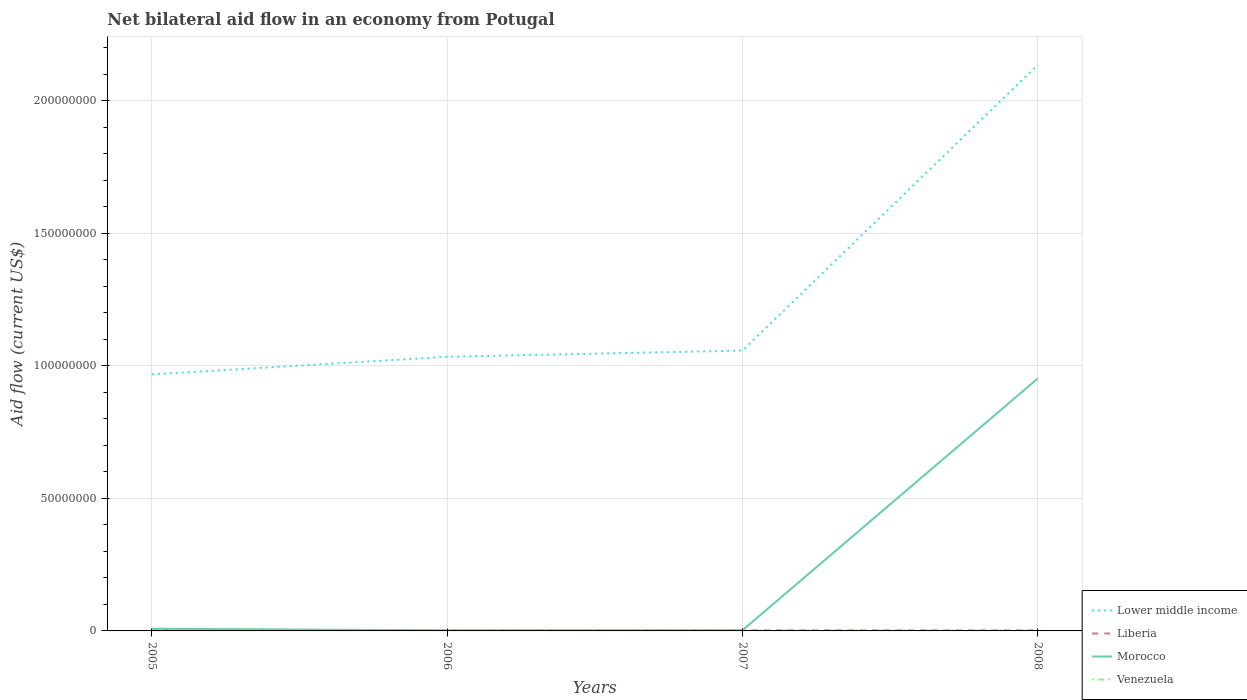How many different coloured lines are there?
Your answer should be very brief. 4. Does the line corresponding to Morocco intersect with the line corresponding to Liberia?
Your response must be concise. No. Across all years, what is the maximum net bilateral aid flow in Lower middle income?
Your answer should be very brief. 9.68e+07. In which year was the net bilateral aid flow in Morocco maximum?
Your answer should be very brief. 2006. What is the total net bilateral aid flow in Morocco in the graph?
Your answer should be compact. -9.50e+07. Is the net bilateral aid flow in Lower middle income strictly greater than the net bilateral aid flow in Morocco over the years?
Provide a succinct answer. No. How many lines are there?
Your answer should be very brief. 4. How many years are there in the graph?
Provide a short and direct response. 4. What is the difference between two consecutive major ticks on the Y-axis?
Make the answer very short. 5.00e+07. Does the graph contain any zero values?
Offer a terse response. No. Does the graph contain grids?
Offer a terse response. Yes. Where does the legend appear in the graph?
Ensure brevity in your answer.  Bottom right. How many legend labels are there?
Offer a terse response. 4. How are the legend labels stacked?
Your answer should be very brief. Vertical. What is the title of the graph?
Give a very brief answer. Net bilateral aid flow in an economy from Potugal. What is the Aid flow (current US$) of Lower middle income in 2005?
Your answer should be very brief. 9.68e+07. What is the Aid flow (current US$) in Liberia in 2005?
Make the answer very short. 5.80e+05. What is the Aid flow (current US$) in Morocco in 2005?
Offer a terse response. 8.30e+05. What is the Aid flow (current US$) of Venezuela in 2005?
Keep it short and to the point. 1.00e+05. What is the Aid flow (current US$) of Lower middle income in 2006?
Ensure brevity in your answer.  1.03e+08. What is the Aid flow (current US$) of Morocco in 2006?
Your response must be concise. 2.30e+05. What is the Aid flow (current US$) in Venezuela in 2006?
Your answer should be compact. 1.10e+05. What is the Aid flow (current US$) of Lower middle income in 2007?
Keep it short and to the point. 1.06e+08. What is the Aid flow (current US$) in Morocco in 2007?
Your answer should be very brief. 2.60e+05. What is the Aid flow (current US$) of Lower middle income in 2008?
Make the answer very short. 2.14e+08. What is the Aid flow (current US$) in Morocco in 2008?
Make the answer very short. 9.53e+07. Across all years, what is the maximum Aid flow (current US$) in Lower middle income?
Offer a terse response. 2.14e+08. Across all years, what is the maximum Aid flow (current US$) of Liberia?
Your answer should be very brief. 5.80e+05. Across all years, what is the maximum Aid flow (current US$) of Morocco?
Keep it short and to the point. 9.53e+07. Across all years, what is the maximum Aid flow (current US$) in Venezuela?
Offer a terse response. 1.50e+05. Across all years, what is the minimum Aid flow (current US$) of Lower middle income?
Provide a succinct answer. 9.68e+07. Across all years, what is the minimum Aid flow (current US$) in Liberia?
Keep it short and to the point. 1.80e+05. Across all years, what is the minimum Aid flow (current US$) of Morocco?
Your answer should be compact. 2.30e+05. What is the total Aid flow (current US$) in Lower middle income in the graph?
Your answer should be very brief. 5.20e+08. What is the total Aid flow (current US$) of Liberia in the graph?
Provide a short and direct response. 1.21e+06. What is the total Aid flow (current US$) in Morocco in the graph?
Ensure brevity in your answer.  9.66e+07. What is the difference between the Aid flow (current US$) of Lower middle income in 2005 and that in 2006?
Give a very brief answer. -6.64e+06. What is the difference between the Aid flow (current US$) of Liberia in 2005 and that in 2006?
Make the answer very short. 4.00e+05. What is the difference between the Aid flow (current US$) in Venezuela in 2005 and that in 2006?
Provide a short and direct response. -10000. What is the difference between the Aid flow (current US$) in Lower middle income in 2005 and that in 2007?
Your response must be concise. -8.99e+06. What is the difference between the Aid flow (current US$) of Morocco in 2005 and that in 2007?
Your answer should be compact. 5.70e+05. What is the difference between the Aid flow (current US$) of Lower middle income in 2005 and that in 2008?
Make the answer very short. -1.17e+08. What is the difference between the Aid flow (current US$) of Liberia in 2005 and that in 2008?
Provide a short and direct response. 3.70e+05. What is the difference between the Aid flow (current US$) of Morocco in 2005 and that in 2008?
Provide a succinct answer. -9.45e+07. What is the difference between the Aid flow (current US$) in Lower middle income in 2006 and that in 2007?
Offer a terse response. -2.35e+06. What is the difference between the Aid flow (current US$) in Liberia in 2006 and that in 2007?
Your response must be concise. -6.00e+04. What is the difference between the Aid flow (current US$) in Morocco in 2006 and that in 2007?
Offer a very short reply. -3.00e+04. What is the difference between the Aid flow (current US$) in Lower middle income in 2006 and that in 2008?
Make the answer very short. -1.10e+08. What is the difference between the Aid flow (current US$) of Liberia in 2006 and that in 2008?
Keep it short and to the point. -3.00e+04. What is the difference between the Aid flow (current US$) of Morocco in 2006 and that in 2008?
Your response must be concise. -9.51e+07. What is the difference between the Aid flow (current US$) of Venezuela in 2006 and that in 2008?
Your response must be concise. -10000. What is the difference between the Aid flow (current US$) of Lower middle income in 2007 and that in 2008?
Your answer should be compact. -1.08e+08. What is the difference between the Aid flow (current US$) in Morocco in 2007 and that in 2008?
Offer a terse response. -9.50e+07. What is the difference between the Aid flow (current US$) of Lower middle income in 2005 and the Aid flow (current US$) of Liberia in 2006?
Your response must be concise. 9.66e+07. What is the difference between the Aid flow (current US$) of Lower middle income in 2005 and the Aid flow (current US$) of Morocco in 2006?
Offer a terse response. 9.66e+07. What is the difference between the Aid flow (current US$) of Lower middle income in 2005 and the Aid flow (current US$) of Venezuela in 2006?
Provide a succinct answer. 9.67e+07. What is the difference between the Aid flow (current US$) in Liberia in 2005 and the Aid flow (current US$) in Venezuela in 2006?
Your answer should be compact. 4.70e+05. What is the difference between the Aid flow (current US$) of Morocco in 2005 and the Aid flow (current US$) of Venezuela in 2006?
Offer a very short reply. 7.20e+05. What is the difference between the Aid flow (current US$) of Lower middle income in 2005 and the Aid flow (current US$) of Liberia in 2007?
Offer a very short reply. 9.66e+07. What is the difference between the Aid flow (current US$) in Lower middle income in 2005 and the Aid flow (current US$) in Morocco in 2007?
Provide a short and direct response. 9.66e+07. What is the difference between the Aid flow (current US$) in Lower middle income in 2005 and the Aid flow (current US$) in Venezuela in 2007?
Offer a very short reply. 9.67e+07. What is the difference between the Aid flow (current US$) in Liberia in 2005 and the Aid flow (current US$) in Morocco in 2007?
Offer a terse response. 3.20e+05. What is the difference between the Aid flow (current US$) in Morocco in 2005 and the Aid flow (current US$) in Venezuela in 2007?
Provide a succinct answer. 6.80e+05. What is the difference between the Aid flow (current US$) in Lower middle income in 2005 and the Aid flow (current US$) in Liberia in 2008?
Offer a terse response. 9.66e+07. What is the difference between the Aid flow (current US$) in Lower middle income in 2005 and the Aid flow (current US$) in Morocco in 2008?
Provide a succinct answer. 1.51e+06. What is the difference between the Aid flow (current US$) of Lower middle income in 2005 and the Aid flow (current US$) of Venezuela in 2008?
Give a very brief answer. 9.67e+07. What is the difference between the Aid flow (current US$) in Liberia in 2005 and the Aid flow (current US$) in Morocco in 2008?
Give a very brief answer. -9.47e+07. What is the difference between the Aid flow (current US$) in Liberia in 2005 and the Aid flow (current US$) in Venezuela in 2008?
Keep it short and to the point. 4.60e+05. What is the difference between the Aid flow (current US$) of Morocco in 2005 and the Aid flow (current US$) of Venezuela in 2008?
Provide a short and direct response. 7.10e+05. What is the difference between the Aid flow (current US$) in Lower middle income in 2006 and the Aid flow (current US$) in Liberia in 2007?
Provide a short and direct response. 1.03e+08. What is the difference between the Aid flow (current US$) in Lower middle income in 2006 and the Aid flow (current US$) in Morocco in 2007?
Your answer should be very brief. 1.03e+08. What is the difference between the Aid flow (current US$) in Lower middle income in 2006 and the Aid flow (current US$) in Venezuela in 2007?
Give a very brief answer. 1.03e+08. What is the difference between the Aid flow (current US$) of Liberia in 2006 and the Aid flow (current US$) of Morocco in 2007?
Provide a short and direct response. -8.00e+04. What is the difference between the Aid flow (current US$) in Lower middle income in 2006 and the Aid flow (current US$) in Liberia in 2008?
Your answer should be very brief. 1.03e+08. What is the difference between the Aid flow (current US$) of Lower middle income in 2006 and the Aid flow (current US$) of Morocco in 2008?
Ensure brevity in your answer.  8.15e+06. What is the difference between the Aid flow (current US$) in Lower middle income in 2006 and the Aid flow (current US$) in Venezuela in 2008?
Offer a very short reply. 1.03e+08. What is the difference between the Aid flow (current US$) in Liberia in 2006 and the Aid flow (current US$) in Morocco in 2008?
Ensure brevity in your answer.  -9.51e+07. What is the difference between the Aid flow (current US$) of Liberia in 2006 and the Aid flow (current US$) of Venezuela in 2008?
Keep it short and to the point. 6.00e+04. What is the difference between the Aid flow (current US$) in Morocco in 2006 and the Aid flow (current US$) in Venezuela in 2008?
Ensure brevity in your answer.  1.10e+05. What is the difference between the Aid flow (current US$) of Lower middle income in 2007 and the Aid flow (current US$) of Liberia in 2008?
Your answer should be compact. 1.06e+08. What is the difference between the Aid flow (current US$) in Lower middle income in 2007 and the Aid flow (current US$) in Morocco in 2008?
Keep it short and to the point. 1.05e+07. What is the difference between the Aid flow (current US$) of Lower middle income in 2007 and the Aid flow (current US$) of Venezuela in 2008?
Keep it short and to the point. 1.06e+08. What is the difference between the Aid flow (current US$) of Liberia in 2007 and the Aid flow (current US$) of Morocco in 2008?
Give a very brief answer. -9.51e+07. What is the difference between the Aid flow (current US$) of Liberia in 2007 and the Aid flow (current US$) of Venezuela in 2008?
Your answer should be compact. 1.20e+05. What is the difference between the Aid flow (current US$) in Morocco in 2007 and the Aid flow (current US$) in Venezuela in 2008?
Your response must be concise. 1.40e+05. What is the average Aid flow (current US$) in Lower middle income per year?
Offer a terse response. 1.30e+08. What is the average Aid flow (current US$) in Liberia per year?
Give a very brief answer. 3.02e+05. What is the average Aid flow (current US$) of Morocco per year?
Provide a succinct answer. 2.42e+07. What is the average Aid flow (current US$) in Venezuela per year?
Offer a very short reply. 1.20e+05. In the year 2005, what is the difference between the Aid flow (current US$) in Lower middle income and Aid flow (current US$) in Liberia?
Offer a terse response. 9.62e+07. In the year 2005, what is the difference between the Aid flow (current US$) of Lower middle income and Aid flow (current US$) of Morocco?
Your answer should be very brief. 9.60e+07. In the year 2005, what is the difference between the Aid flow (current US$) in Lower middle income and Aid flow (current US$) in Venezuela?
Offer a very short reply. 9.67e+07. In the year 2005, what is the difference between the Aid flow (current US$) of Liberia and Aid flow (current US$) of Venezuela?
Your answer should be compact. 4.80e+05. In the year 2005, what is the difference between the Aid flow (current US$) of Morocco and Aid flow (current US$) of Venezuela?
Keep it short and to the point. 7.30e+05. In the year 2006, what is the difference between the Aid flow (current US$) in Lower middle income and Aid flow (current US$) in Liberia?
Keep it short and to the point. 1.03e+08. In the year 2006, what is the difference between the Aid flow (current US$) in Lower middle income and Aid flow (current US$) in Morocco?
Provide a short and direct response. 1.03e+08. In the year 2006, what is the difference between the Aid flow (current US$) in Lower middle income and Aid flow (current US$) in Venezuela?
Offer a very short reply. 1.03e+08. In the year 2007, what is the difference between the Aid flow (current US$) of Lower middle income and Aid flow (current US$) of Liberia?
Provide a short and direct response. 1.06e+08. In the year 2007, what is the difference between the Aid flow (current US$) of Lower middle income and Aid flow (current US$) of Morocco?
Your response must be concise. 1.06e+08. In the year 2007, what is the difference between the Aid flow (current US$) in Lower middle income and Aid flow (current US$) in Venezuela?
Provide a short and direct response. 1.06e+08. In the year 2007, what is the difference between the Aid flow (current US$) of Liberia and Aid flow (current US$) of Venezuela?
Ensure brevity in your answer.  9.00e+04. In the year 2007, what is the difference between the Aid flow (current US$) of Morocco and Aid flow (current US$) of Venezuela?
Make the answer very short. 1.10e+05. In the year 2008, what is the difference between the Aid flow (current US$) of Lower middle income and Aid flow (current US$) of Liberia?
Provide a short and direct response. 2.13e+08. In the year 2008, what is the difference between the Aid flow (current US$) in Lower middle income and Aid flow (current US$) in Morocco?
Give a very brief answer. 1.18e+08. In the year 2008, what is the difference between the Aid flow (current US$) of Lower middle income and Aid flow (current US$) of Venezuela?
Provide a short and direct response. 2.13e+08. In the year 2008, what is the difference between the Aid flow (current US$) in Liberia and Aid flow (current US$) in Morocco?
Give a very brief answer. -9.51e+07. In the year 2008, what is the difference between the Aid flow (current US$) of Morocco and Aid flow (current US$) of Venezuela?
Ensure brevity in your answer.  9.52e+07. What is the ratio of the Aid flow (current US$) of Lower middle income in 2005 to that in 2006?
Your answer should be very brief. 0.94. What is the ratio of the Aid flow (current US$) of Liberia in 2005 to that in 2006?
Provide a short and direct response. 3.22. What is the ratio of the Aid flow (current US$) in Morocco in 2005 to that in 2006?
Provide a short and direct response. 3.61. What is the ratio of the Aid flow (current US$) of Venezuela in 2005 to that in 2006?
Offer a very short reply. 0.91. What is the ratio of the Aid flow (current US$) in Lower middle income in 2005 to that in 2007?
Make the answer very short. 0.92. What is the ratio of the Aid flow (current US$) of Liberia in 2005 to that in 2007?
Provide a succinct answer. 2.42. What is the ratio of the Aid flow (current US$) in Morocco in 2005 to that in 2007?
Provide a succinct answer. 3.19. What is the ratio of the Aid flow (current US$) in Lower middle income in 2005 to that in 2008?
Provide a short and direct response. 0.45. What is the ratio of the Aid flow (current US$) of Liberia in 2005 to that in 2008?
Offer a very short reply. 2.76. What is the ratio of the Aid flow (current US$) in Morocco in 2005 to that in 2008?
Your answer should be compact. 0.01. What is the ratio of the Aid flow (current US$) in Lower middle income in 2006 to that in 2007?
Provide a succinct answer. 0.98. What is the ratio of the Aid flow (current US$) of Liberia in 2006 to that in 2007?
Give a very brief answer. 0.75. What is the ratio of the Aid flow (current US$) of Morocco in 2006 to that in 2007?
Ensure brevity in your answer.  0.88. What is the ratio of the Aid flow (current US$) of Venezuela in 2006 to that in 2007?
Provide a succinct answer. 0.73. What is the ratio of the Aid flow (current US$) in Lower middle income in 2006 to that in 2008?
Give a very brief answer. 0.48. What is the ratio of the Aid flow (current US$) of Liberia in 2006 to that in 2008?
Ensure brevity in your answer.  0.86. What is the ratio of the Aid flow (current US$) in Morocco in 2006 to that in 2008?
Give a very brief answer. 0. What is the ratio of the Aid flow (current US$) of Lower middle income in 2007 to that in 2008?
Offer a terse response. 0.5. What is the ratio of the Aid flow (current US$) of Morocco in 2007 to that in 2008?
Provide a short and direct response. 0. What is the difference between the highest and the second highest Aid flow (current US$) in Lower middle income?
Your answer should be very brief. 1.08e+08. What is the difference between the highest and the second highest Aid flow (current US$) in Liberia?
Make the answer very short. 3.40e+05. What is the difference between the highest and the second highest Aid flow (current US$) of Morocco?
Offer a terse response. 9.45e+07. What is the difference between the highest and the second highest Aid flow (current US$) of Venezuela?
Offer a very short reply. 3.00e+04. What is the difference between the highest and the lowest Aid flow (current US$) in Lower middle income?
Keep it short and to the point. 1.17e+08. What is the difference between the highest and the lowest Aid flow (current US$) in Liberia?
Offer a terse response. 4.00e+05. What is the difference between the highest and the lowest Aid flow (current US$) in Morocco?
Provide a short and direct response. 9.51e+07. 